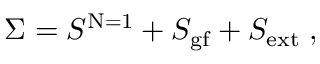<formula> <loc_0><loc_0><loc_500><loc_500>\Sigma = S ^ { N = 1 } + S _ { g f } + S _ { e x t } \, ,</formula> 